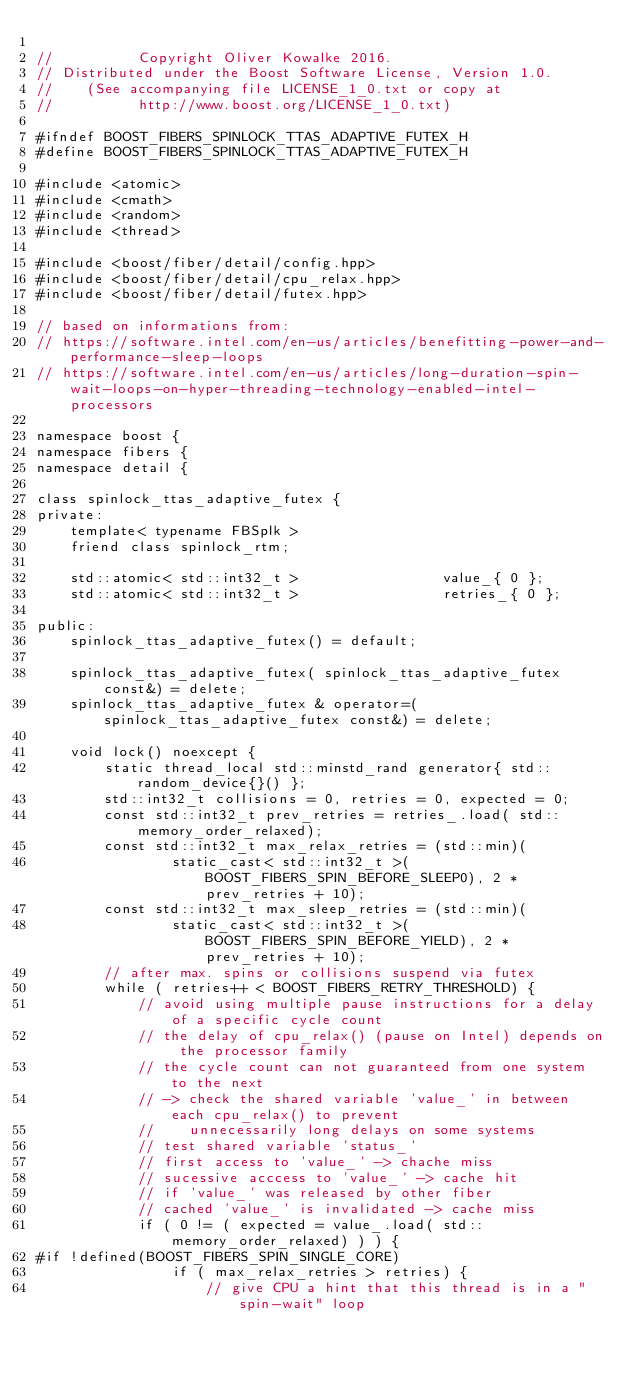Convert code to text. <code><loc_0><loc_0><loc_500><loc_500><_C++_>
//          Copyright Oliver Kowalke 2016.
// Distributed under the Boost Software License, Version 1.0.
//    (See accompanying file LICENSE_1_0.txt or copy at
//          http://www.boost.org/LICENSE_1_0.txt)

#ifndef BOOST_FIBERS_SPINLOCK_TTAS_ADAPTIVE_FUTEX_H
#define BOOST_FIBERS_SPINLOCK_TTAS_ADAPTIVE_FUTEX_H

#include <atomic>
#include <cmath>
#include <random>
#include <thread>

#include <boost/fiber/detail/config.hpp>
#include <boost/fiber/detail/cpu_relax.hpp>
#include <boost/fiber/detail/futex.hpp>

// based on informations from:
// https://software.intel.com/en-us/articles/benefitting-power-and-performance-sleep-loops
// https://software.intel.com/en-us/articles/long-duration-spin-wait-loops-on-hyper-threading-technology-enabled-intel-processors

namespace boost {
namespace fibers {
namespace detail {

class spinlock_ttas_adaptive_futex {
private:
    template< typename FBSplk >
    friend class spinlock_rtm;

    std::atomic< std::int32_t >                 value_{ 0 };
    std::atomic< std::int32_t >                 retries_{ 0 };

public:
    spinlock_ttas_adaptive_futex() = default;

    spinlock_ttas_adaptive_futex( spinlock_ttas_adaptive_futex const&) = delete;
    spinlock_ttas_adaptive_futex & operator=( spinlock_ttas_adaptive_futex const&) = delete;

    void lock() noexcept {
        static thread_local std::minstd_rand generator{ std::random_device{}() };
        std::int32_t collisions = 0, retries = 0, expected = 0;
        const std::int32_t prev_retries = retries_.load( std::memory_order_relaxed);
        const std::int32_t max_relax_retries = (std::min)(
                static_cast< std::int32_t >( BOOST_FIBERS_SPIN_BEFORE_SLEEP0), 2 * prev_retries + 10);
        const std::int32_t max_sleep_retries = (std::min)(
                static_cast< std::int32_t >( BOOST_FIBERS_SPIN_BEFORE_YIELD), 2 * prev_retries + 10);
        // after max. spins or collisions suspend via futex
        while ( retries++ < BOOST_FIBERS_RETRY_THRESHOLD) {
            // avoid using multiple pause instructions for a delay of a specific cycle count
            // the delay of cpu_relax() (pause on Intel) depends on the processor family
            // the cycle count can not guaranteed from one system to the next
            // -> check the shared variable 'value_' in between each cpu_relax() to prevent
            //    unnecessarily long delays on some systems
            // test shared variable 'status_'
            // first access to 'value_' -> chache miss
            // sucessive acccess to 'value_' -> cache hit
            // if 'value_' was released by other fiber
            // cached 'value_' is invalidated -> cache miss
            if ( 0 != ( expected = value_.load( std::memory_order_relaxed) ) ) {
#if !defined(BOOST_FIBERS_SPIN_SINGLE_CORE)
                if ( max_relax_retries > retries) {
                    // give CPU a hint that this thread is in a "spin-wait" loop</code> 